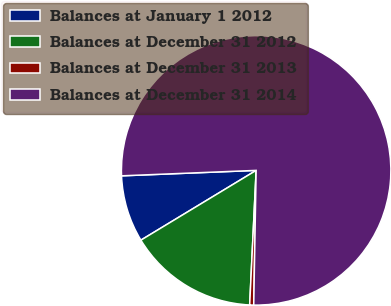Convert chart to OTSL. <chart><loc_0><loc_0><loc_500><loc_500><pie_chart><fcel>Balances at January 1 2012<fcel>Balances at December 31 2012<fcel>Balances at December 31 2013<fcel>Balances at December 31 2014<nl><fcel>8.02%<fcel>15.57%<fcel>0.48%<fcel>75.93%<nl></chart> 